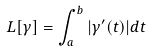Convert formula to latex. <formula><loc_0><loc_0><loc_500><loc_500>L [ \gamma ] = \int _ { a } ^ { b } | \gamma ^ { \prime } ( t ) | d t</formula> 